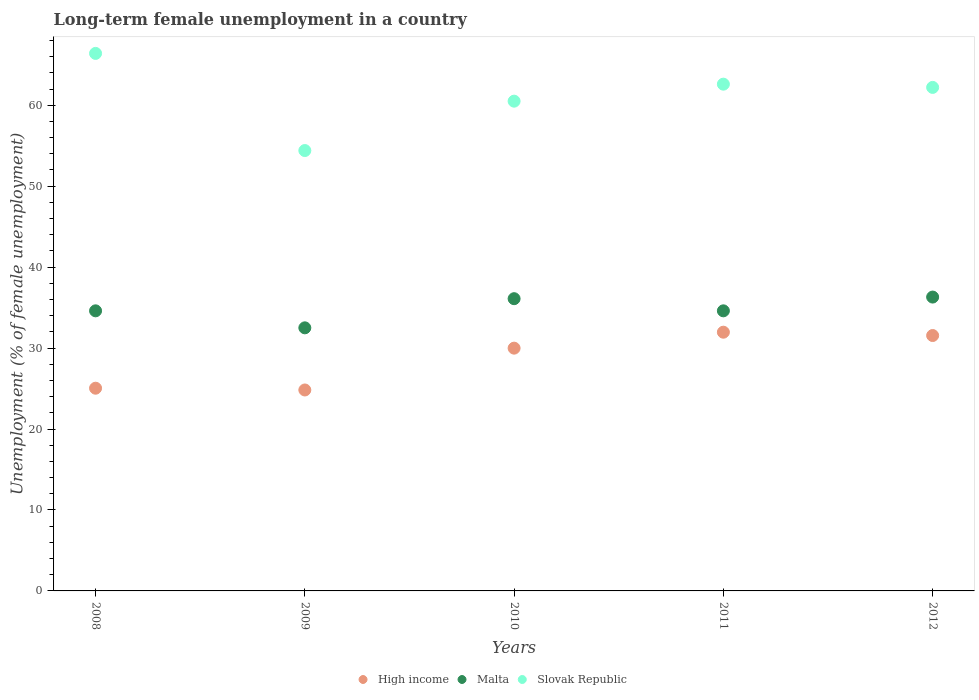How many different coloured dotlines are there?
Provide a short and direct response. 3. Is the number of dotlines equal to the number of legend labels?
Give a very brief answer. Yes. What is the percentage of long-term unemployed female population in Malta in 2008?
Your answer should be compact. 34.6. Across all years, what is the maximum percentage of long-term unemployed female population in Slovak Republic?
Provide a succinct answer. 66.4. Across all years, what is the minimum percentage of long-term unemployed female population in Slovak Republic?
Give a very brief answer. 54.4. In which year was the percentage of long-term unemployed female population in Slovak Republic maximum?
Your answer should be very brief. 2008. What is the total percentage of long-term unemployed female population in High income in the graph?
Keep it short and to the point. 143.36. What is the difference between the percentage of long-term unemployed female population in Malta in 2008 and that in 2009?
Ensure brevity in your answer.  2.1. What is the difference between the percentage of long-term unemployed female population in Slovak Republic in 2011 and the percentage of long-term unemployed female population in Malta in 2009?
Provide a succinct answer. 30.1. What is the average percentage of long-term unemployed female population in Malta per year?
Offer a very short reply. 34.82. In the year 2012, what is the difference between the percentage of long-term unemployed female population in High income and percentage of long-term unemployed female population in Malta?
Ensure brevity in your answer.  -4.75. What is the ratio of the percentage of long-term unemployed female population in Malta in 2009 to that in 2011?
Give a very brief answer. 0.94. Is the difference between the percentage of long-term unemployed female population in High income in 2009 and 2010 greater than the difference between the percentage of long-term unemployed female population in Malta in 2009 and 2010?
Keep it short and to the point. No. What is the difference between the highest and the second highest percentage of long-term unemployed female population in Malta?
Offer a very short reply. 0.2. What is the difference between the highest and the lowest percentage of long-term unemployed female population in Slovak Republic?
Give a very brief answer. 12. In how many years, is the percentage of long-term unemployed female population in Malta greater than the average percentage of long-term unemployed female population in Malta taken over all years?
Your answer should be very brief. 2. Is the sum of the percentage of long-term unemployed female population in Slovak Republic in 2009 and 2010 greater than the maximum percentage of long-term unemployed female population in Malta across all years?
Ensure brevity in your answer.  Yes. Does the percentage of long-term unemployed female population in High income monotonically increase over the years?
Your answer should be compact. No. Is the percentage of long-term unemployed female population in High income strictly less than the percentage of long-term unemployed female population in Malta over the years?
Your answer should be very brief. Yes. How many dotlines are there?
Provide a short and direct response. 3. Does the graph contain grids?
Provide a succinct answer. No. Where does the legend appear in the graph?
Provide a succinct answer. Bottom center. How are the legend labels stacked?
Provide a succinct answer. Horizontal. What is the title of the graph?
Provide a short and direct response. Long-term female unemployment in a country. What is the label or title of the X-axis?
Ensure brevity in your answer.  Years. What is the label or title of the Y-axis?
Ensure brevity in your answer.  Unemployment (% of female unemployment). What is the Unemployment (% of female unemployment) in High income in 2008?
Provide a succinct answer. 25.04. What is the Unemployment (% of female unemployment) in Malta in 2008?
Provide a succinct answer. 34.6. What is the Unemployment (% of female unemployment) of Slovak Republic in 2008?
Your response must be concise. 66.4. What is the Unemployment (% of female unemployment) of High income in 2009?
Offer a very short reply. 24.82. What is the Unemployment (% of female unemployment) in Malta in 2009?
Give a very brief answer. 32.5. What is the Unemployment (% of female unemployment) in Slovak Republic in 2009?
Make the answer very short. 54.4. What is the Unemployment (% of female unemployment) in High income in 2010?
Offer a terse response. 29.99. What is the Unemployment (% of female unemployment) of Malta in 2010?
Your response must be concise. 36.1. What is the Unemployment (% of female unemployment) of Slovak Republic in 2010?
Keep it short and to the point. 60.5. What is the Unemployment (% of female unemployment) in High income in 2011?
Your response must be concise. 31.96. What is the Unemployment (% of female unemployment) in Malta in 2011?
Make the answer very short. 34.6. What is the Unemployment (% of female unemployment) of Slovak Republic in 2011?
Offer a very short reply. 62.6. What is the Unemployment (% of female unemployment) in High income in 2012?
Keep it short and to the point. 31.55. What is the Unemployment (% of female unemployment) of Malta in 2012?
Your answer should be compact. 36.3. What is the Unemployment (% of female unemployment) in Slovak Republic in 2012?
Ensure brevity in your answer.  62.2. Across all years, what is the maximum Unemployment (% of female unemployment) of High income?
Give a very brief answer. 31.96. Across all years, what is the maximum Unemployment (% of female unemployment) of Malta?
Your response must be concise. 36.3. Across all years, what is the maximum Unemployment (% of female unemployment) of Slovak Republic?
Provide a short and direct response. 66.4. Across all years, what is the minimum Unemployment (% of female unemployment) in High income?
Your answer should be compact. 24.82. Across all years, what is the minimum Unemployment (% of female unemployment) in Malta?
Offer a terse response. 32.5. Across all years, what is the minimum Unemployment (% of female unemployment) in Slovak Republic?
Keep it short and to the point. 54.4. What is the total Unemployment (% of female unemployment) of High income in the graph?
Provide a succinct answer. 143.36. What is the total Unemployment (% of female unemployment) in Malta in the graph?
Make the answer very short. 174.1. What is the total Unemployment (% of female unemployment) of Slovak Republic in the graph?
Your response must be concise. 306.1. What is the difference between the Unemployment (% of female unemployment) of High income in 2008 and that in 2009?
Offer a terse response. 0.22. What is the difference between the Unemployment (% of female unemployment) of Slovak Republic in 2008 and that in 2009?
Your answer should be compact. 12. What is the difference between the Unemployment (% of female unemployment) of High income in 2008 and that in 2010?
Provide a short and direct response. -4.95. What is the difference between the Unemployment (% of female unemployment) in Malta in 2008 and that in 2010?
Make the answer very short. -1.5. What is the difference between the Unemployment (% of female unemployment) of High income in 2008 and that in 2011?
Offer a very short reply. -6.92. What is the difference between the Unemployment (% of female unemployment) of Malta in 2008 and that in 2011?
Ensure brevity in your answer.  0. What is the difference between the Unemployment (% of female unemployment) in High income in 2008 and that in 2012?
Offer a terse response. -6.51. What is the difference between the Unemployment (% of female unemployment) in Malta in 2008 and that in 2012?
Offer a terse response. -1.7. What is the difference between the Unemployment (% of female unemployment) of Slovak Republic in 2008 and that in 2012?
Keep it short and to the point. 4.2. What is the difference between the Unemployment (% of female unemployment) in High income in 2009 and that in 2010?
Keep it short and to the point. -5.17. What is the difference between the Unemployment (% of female unemployment) in High income in 2009 and that in 2011?
Your answer should be compact. -7.14. What is the difference between the Unemployment (% of female unemployment) in High income in 2009 and that in 2012?
Offer a very short reply. -6.73. What is the difference between the Unemployment (% of female unemployment) of Malta in 2009 and that in 2012?
Your response must be concise. -3.8. What is the difference between the Unemployment (% of female unemployment) in Slovak Republic in 2009 and that in 2012?
Your answer should be compact. -7.8. What is the difference between the Unemployment (% of female unemployment) in High income in 2010 and that in 2011?
Offer a terse response. -1.97. What is the difference between the Unemployment (% of female unemployment) in Malta in 2010 and that in 2011?
Offer a very short reply. 1.5. What is the difference between the Unemployment (% of female unemployment) in High income in 2010 and that in 2012?
Provide a short and direct response. -1.56. What is the difference between the Unemployment (% of female unemployment) in High income in 2011 and that in 2012?
Provide a short and direct response. 0.41. What is the difference between the Unemployment (% of female unemployment) in Malta in 2011 and that in 2012?
Provide a short and direct response. -1.7. What is the difference between the Unemployment (% of female unemployment) of High income in 2008 and the Unemployment (% of female unemployment) of Malta in 2009?
Provide a succinct answer. -7.46. What is the difference between the Unemployment (% of female unemployment) of High income in 2008 and the Unemployment (% of female unemployment) of Slovak Republic in 2009?
Ensure brevity in your answer.  -29.36. What is the difference between the Unemployment (% of female unemployment) in Malta in 2008 and the Unemployment (% of female unemployment) in Slovak Republic in 2009?
Your answer should be very brief. -19.8. What is the difference between the Unemployment (% of female unemployment) of High income in 2008 and the Unemployment (% of female unemployment) of Malta in 2010?
Keep it short and to the point. -11.06. What is the difference between the Unemployment (% of female unemployment) in High income in 2008 and the Unemployment (% of female unemployment) in Slovak Republic in 2010?
Provide a succinct answer. -35.46. What is the difference between the Unemployment (% of female unemployment) in Malta in 2008 and the Unemployment (% of female unemployment) in Slovak Republic in 2010?
Offer a very short reply. -25.9. What is the difference between the Unemployment (% of female unemployment) in High income in 2008 and the Unemployment (% of female unemployment) in Malta in 2011?
Keep it short and to the point. -9.56. What is the difference between the Unemployment (% of female unemployment) of High income in 2008 and the Unemployment (% of female unemployment) of Slovak Republic in 2011?
Make the answer very short. -37.56. What is the difference between the Unemployment (% of female unemployment) in High income in 2008 and the Unemployment (% of female unemployment) in Malta in 2012?
Provide a short and direct response. -11.26. What is the difference between the Unemployment (% of female unemployment) in High income in 2008 and the Unemployment (% of female unemployment) in Slovak Republic in 2012?
Make the answer very short. -37.16. What is the difference between the Unemployment (% of female unemployment) in Malta in 2008 and the Unemployment (% of female unemployment) in Slovak Republic in 2012?
Give a very brief answer. -27.6. What is the difference between the Unemployment (% of female unemployment) of High income in 2009 and the Unemployment (% of female unemployment) of Malta in 2010?
Provide a succinct answer. -11.28. What is the difference between the Unemployment (% of female unemployment) of High income in 2009 and the Unemployment (% of female unemployment) of Slovak Republic in 2010?
Provide a short and direct response. -35.68. What is the difference between the Unemployment (% of female unemployment) of Malta in 2009 and the Unemployment (% of female unemployment) of Slovak Republic in 2010?
Offer a very short reply. -28. What is the difference between the Unemployment (% of female unemployment) of High income in 2009 and the Unemployment (% of female unemployment) of Malta in 2011?
Ensure brevity in your answer.  -9.78. What is the difference between the Unemployment (% of female unemployment) in High income in 2009 and the Unemployment (% of female unemployment) in Slovak Republic in 2011?
Make the answer very short. -37.78. What is the difference between the Unemployment (% of female unemployment) in Malta in 2009 and the Unemployment (% of female unemployment) in Slovak Republic in 2011?
Your answer should be very brief. -30.1. What is the difference between the Unemployment (% of female unemployment) of High income in 2009 and the Unemployment (% of female unemployment) of Malta in 2012?
Ensure brevity in your answer.  -11.48. What is the difference between the Unemployment (% of female unemployment) of High income in 2009 and the Unemployment (% of female unemployment) of Slovak Republic in 2012?
Your answer should be compact. -37.38. What is the difference between the Unemployment (% of female unemployment) of Malta in 2009 and the Unemployment (% of female unemployment) of Slovak Republic in 2012?
Your answer should be compact. -29.7. What is the difference between the Unemployment (% of female unemployment) in High income in 2010 and the Unemployment (% of female unemployment) in Malta in 2011?
Offer a terse response. -4.61. What is the difference between the Unemployment (% of female unemployment) of High income in 2010 and the Unemployment (% of female unemployment) of Slovak Republic in 2011?
Ensure brevity in your answer.  -32.61. What is the difference between the Unemployment (% of female unemployment) in Malta in 2010 and the Unemployment (% of female unemployment) in Slovak Republic in 2011?
Your answer should be very brief. -26.5. What is the difference between the Unemployment (% of female unemployment) of High income in 2010 and the Unemployment (% of female unemployment) of Malta in 2012?
Provide a succinct answer. -6.31. What is the difference between the Unemployment (% of female unemployment) of High income in 2010 and the Unemployment (% of female unemployment) of Slovak Republic in 2012?
Offer a terse response. -32.21. What is the difference between the Unemployment (% of female unemployment) of Malta in 2010 and the Unemployment (% of female unemployment) of Slovak Republic in 2012?
Make the answer very short. -26.1. What is the difference between the Unemployment (% of female unemployment) in High income in 2011 and the Unemployment (% of female unemployment) in Malta in 2012?
Your response must be concise. -4.34. What is the difference between the Unemployment (% of female unemployment) of High income in 2011 and the Unemployment (% of female unemployment) of Slovak Republic in 2012?
Provide a short and direct response. -30.24. What is the difference between the Unemployment (% of female unemployment) of Malta in 2011 and the Unemployment (% of female unemployment) of Slovak Republic in 2012?
Offer a very short reply. -27.6. What is the average Unemployment (% of female unemployment) in High income per year?
Provide a short and direct response. 28.67. What is the average Unemployment (% of female unemployment) in Malta per year?
Offer a very short reply. 34.82. What is the average Unemployment (% of female unemployment) in Slovak Republic per year?
Give a very brief answer. 61.22. In the year 2008, what is the difference between the Unemployment (% of female unemployment) in High income and Unemployment (% of female unemployment) in Malta?
Provide a short and direct response. -9.56. In the year 2008, what is the difference between the Unemployment (% of female unemployment) of High income and Unemployment (% of female unemployment) of Slovak Republic?
Make the answer very short. -41.36. In the year 2008, what is the difference between the Unemployment (% of female unemployment) in Malta and Unemployment (% of female unemployment) in Slovak Republic?
Make the answer very short. -31.8. In the year 2009, what is the difference between the Unemployment (% of female unemployment) in High income and Unemployment (% of female unemployment) in Malta?
Provide a succinct answer. -7.68. In the year 2009, what is the difference between the Unemployment (% of female unemployment) of High income and Unemployment (% of female unemployment) of Slovak Republic?
Offer a very short reply. -29.58. In the year 2009, what is the difference between the Unemployment (% of female unemployment) in Malta and Unemployment (% of female unemployment) in Slovak Republic?
Provide a short and direct response. -21.9. In the year 2010, what is the difference between the Unemployment (% of female unemployment) in High income and Unemployment (% of female unemployment) in Malta?
Offer a terse response. -6.11. In the year 2010, what is the difference between the Unemployment (% of female unemployment) in High income and Unemployment (% of female unemployment) in Slovak Republic?
Ensure brevity in your answer.  -30.51. In the year 2010, what is the difference between the Unemployment (% of female unemployment) in Malta and Unemployment (% of female unemployment) in Slovak Republic?
Ensure brevity in your answer.  -24.4. In the year 2011, what is the difference between the Unemployment (% of female unemployment) in High income and Unemployment (% of female unemployment) in Malta?
Your response must be concise. -2.64. In the year 2011, what is the difference between the Unemployment (% of female unemployment) of High income and Unemployment (% of female unemployment) of Slovak Republic?
Your answer should be very brief. -30.64. In the year 2012, what is the difference between the Unemployment (% of female unemployment) in High income and Unemployment (% of female unemployment) in Malta?
Provide a short and direct response. -4.75. In the year 2012, what is the difference between the Unemployment (% of female unemployment) of High income and Unemployment (% of female unemployment) of Slovak Republic?
Provide a short and direct response. -30.65. In the year 2012, what is the difference between the Unemployment (% of female unemployment) of Malta and Unemployment (% of female unemployment) of Slovak Republic?
Offer a very short reply. -25.9. What is the ratio of the Unemployment (% of female unemployment) of High income in 2008 to that in 2009?
Keep it short and to the point. 1.01. What is the ratio of the Unemployment (% of female unemployment) of Malta in 2008 to that in 2009?
Give a very brief answer. 1.06. What is the ratio of the Unemployment (% of female unemployment) of Slovak Republic in 2008 to that in 2009?
Keep it short and to the point. 1.22. What is the ratio of the Unemployment (% of female unemployment) of High income in 2008 to that in 2010?
Give a very brief answer. 0.83. What is the ratio of the Unemployment (% of female unemployment) of Malta in 2008 to that in 2010?
Your answer should be very brief. 0.96. What is the ratio of the Unemployment (% of female unemployment) in Slovak Republic in 2008 to that in 2010?
Make the answer very short. 1.1. What is the ratio of the Unemployment (% of female unemployment) in High income in 2008 to that in 2011?
Provide a short and direct response. 0.78. What is the ratio of the Unemployment (% of female unemployment) of Slovak Republic in 2008 to that in 2011?
Your answer should be very brief. 1.06. What is the ratio of the Unemployment (% of female unemployment) of High income in 2008 to that in 2012?
Keep it short and to the point. 0.79. What is the ratio of the Unemployment (% of female unemployment) of Malta in 2008 to that in 2012?
Make the answer very short. 0.95. What is the ratio of the Unemployment (% of female unemployment) of Slovak Republic in 2008 to that in 2012?
Your answer should be compact. 1.07. What is the ratio of the Unemployment (% of female unemployment) of High income in 2009 to that in 2010?
Give a very brief answer. 0.83. What is the ratio of the Unemployment (% of female unemployment) of Malta in 2009 to that in 2010?
Ensure brevity in your answer.  0.9. What is the ratio of the Unemployment (% of female unemployment) of Slovak Republic in 2009 to that in 2010?
Offer a terse response. 0.9. What is the ratio of the Unemployment (% of female unemployment) of High income in 2009 to that in 2011?
Ensure brevity in your answer.  0.78. What is the ratio of the Unemployment (% of female unemployment) in Malta in 2009 to that in 2011?
Your answer should be compact. 0.94. What is the ratio of the Unemployment (% of female unemployment) of Slovak Republic in 2009 to that in 2011?
Offer a terse response. 0.87. What is the ratio of the Unemployment (% of female unemployment) in High income in 2009 to that in 2012?
Ensure brevity in your answer.  0.79. What is the ratio of the Unemployment (% of female unemployment) in Malta in 2009 to that in 2012?
Provide a short and direct response. 0.9. What is the ratio of the Unemployment (% of female unemployment) of Slovak Republic in 2009 to that in 2012?
Give a very brief answer. 0.87. What is the ratio of the Unemployment (% of female unemployment) of High income in 2010 to that in 2011?
Your answer should be very brief. 0.94. What is the ratio of the Unemployment (% of female unemployment) in Malta in 2010 to that in 2011?
Your answer should be very brief. 1.04. What is the ratio of the Unemployment (% of female unemployment) in Slovak Republic in 2010 to that in 2011?
Make the answer very short. 0.97. What is the ratio of the Unemployment (% of female unemployment) of High income in 2010 to that in 2012?
Ensure brevity in your answer.  0.95. What is the ratio of the Unemployment (% of female unemployment) in Malta in 2010 to that in 2012?
Provide a succinct answer. 0.99. What is the ratio of the Unemployment (% of female unemployment) in Slovak Republic in 2010 to that in 2012?
Your answer should be very brief. 0.97. What is the ratio of the Unemployment (% of female unemployment) of High income in 2011 to that in 2012?
Keep it short and to the point. 1.01. What is the ratio of the Unemployment (% of female unemployment) of Malta in 2011 to that in 2012?
Your response must be concise. 0.95. What is the ratio of the Unemployment (% of female unemployment) in Slovak Republic in 2011 to that in 2012?
Offer a very short reply. 1.01. What is the difference between the highest and the second highest Unemployment (% of female unemployment) of High income?
Your response must be concise. 0.41. What is the difference between the highest and the second highest Unemployment (% of female unemployment) of Malta?
Your response must be concise. 0.2. What is the difference between the highest and the lowest Unemployment (% of female unemployment) of High income?
Ensure brevity in your answer.  7.14. 